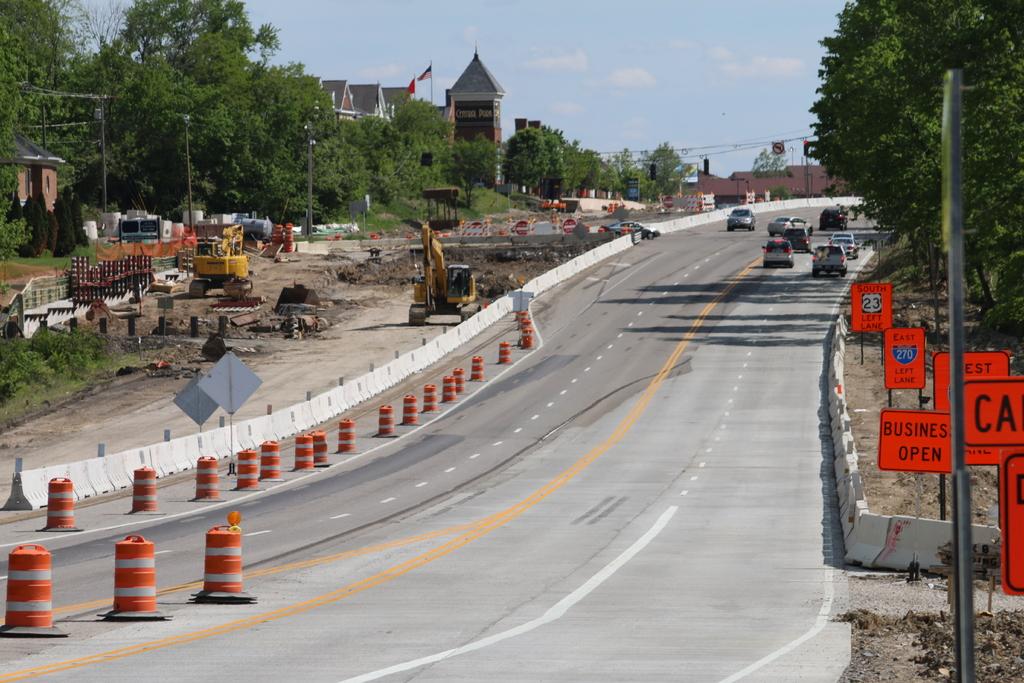What is open?
Provide a short and direct response. Business. What eastward interstate is the left lane for?
Make the answer very short. 270. 